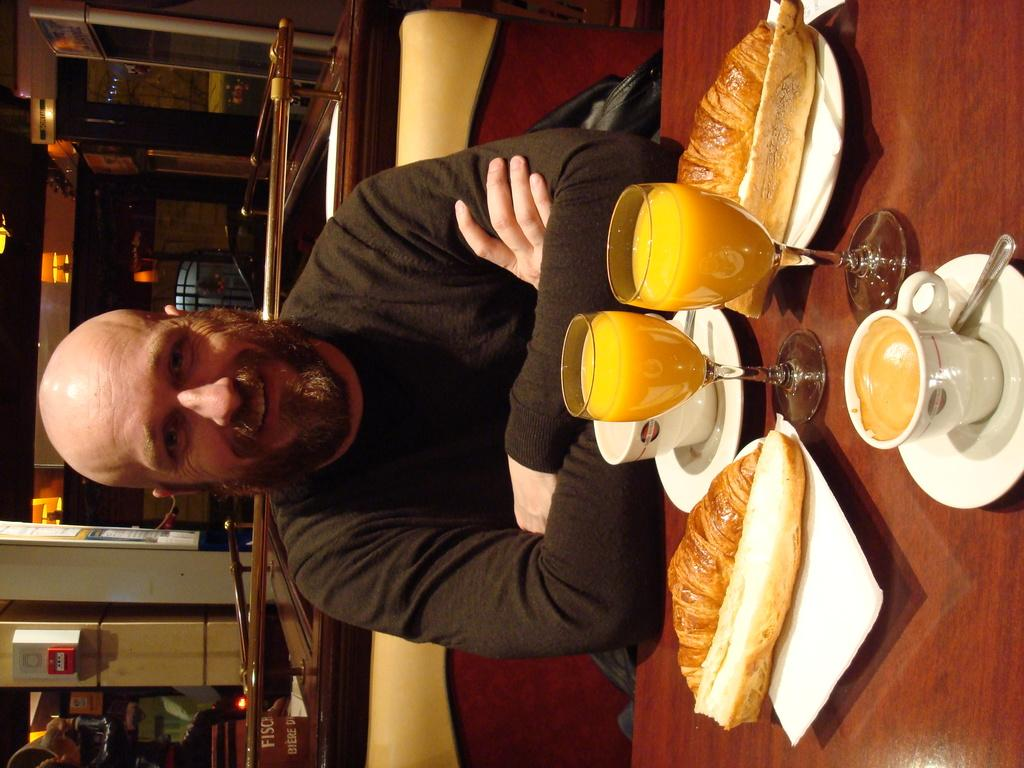Who or what is present in the image? There is a person in the image. What is the person wearing? The person is wearing clothes. Where is the person located in relation to the table? The person is sitting in front of a table. What items can be found on the table? The table contains glasses, cups, and food. What type of coal is being used to fuel the fire on the island in the image? There is no coal, fire, or island present in the image. 